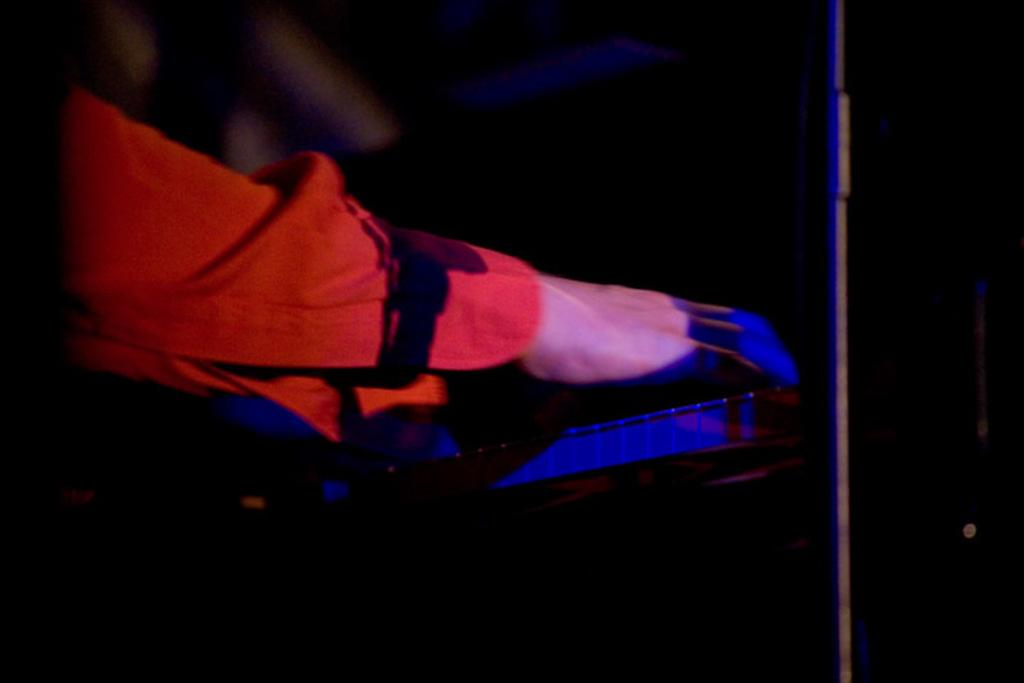What is the main subject of the image? The main subject of the image is a person's hand. What can be seen in the background of the image? The background of the image is dark. What object is located on the right side of the image? There is a pole on the right side of the image. What is the person's hand doing in the image? The provided facts do not specify any action or activity involving the person's hand. What is the person's interest in the pole on the right side of the image? The provided facts do not indicate any interest or interaction between the person's hand and the pole. 